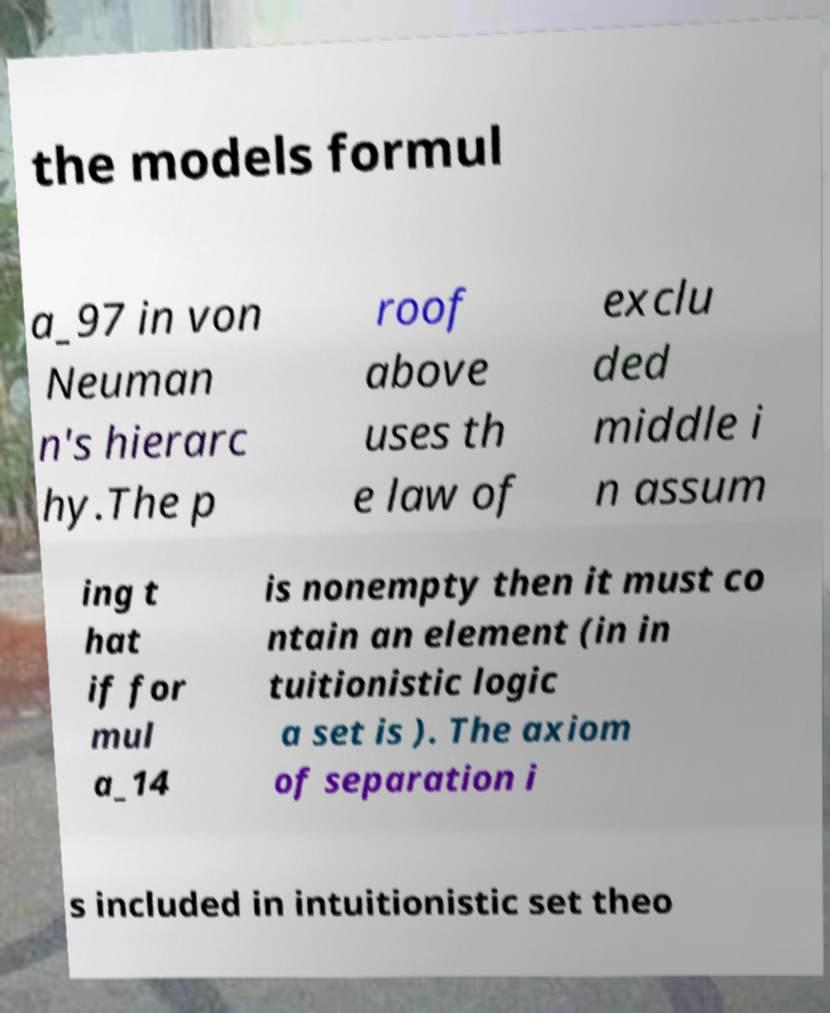Could you extract and type out the text from this image? the models formul a_97 in von Neuman n's hierarc hy.The p roof above uses th e law of exclu ded middle i n assum ing t hat if for mul a_14 is nonempty then it must co ntain an element (in in tuitionistic logic a set is ). The axiom of separation i s included in intuitionistic set theo 